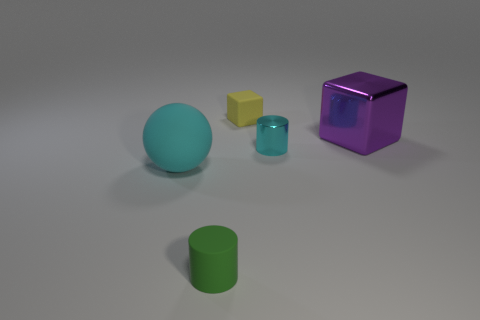Add 4 large purple blocks. How many objects exist? 9 Subtract all green cylinders. How many cylinders are left? 1 Subtract 1 blocks. How many blocks are left? 1 Subtract all cubes. How many objects are left? 3 Subtract all purple balls. Subtract all green cubes. How many balls are left? 1 Subtract all tiny gray rubber spheres. Subtract all cyan matte spheres. How many objects are left? 4 Add 1 yellow things. How many yellow things are left? 2 Add 5 tiny gray metal cubes. How many tiny gray metal cubes exist? 5 Subtract 0 red cylinders. How many objects are left? 5 